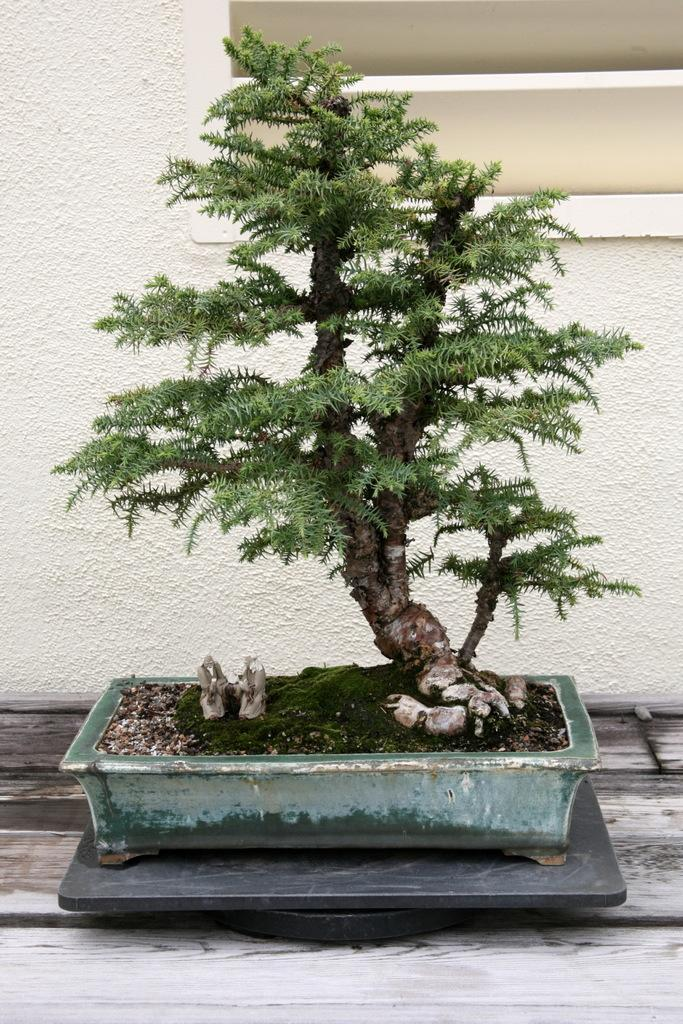What type of plant is in the image? There is a bonsai plant in the image. Where is the bonsai plant located? The bonsai plant is in a pot. What other objects can be seen in the image? There are black marbles in the image. What is the surface that the bonsai plant and marbles are placed on? There is a wooden surface in the image. What is visible in the background of the image? The background of the image includes a white wall. What type of learning is taking place in the image? There is no indication of learning or any educational activity in the image. 